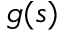<formula> <loc_0><loc_0><loc_500><loc_500>g ( s )</formula> 